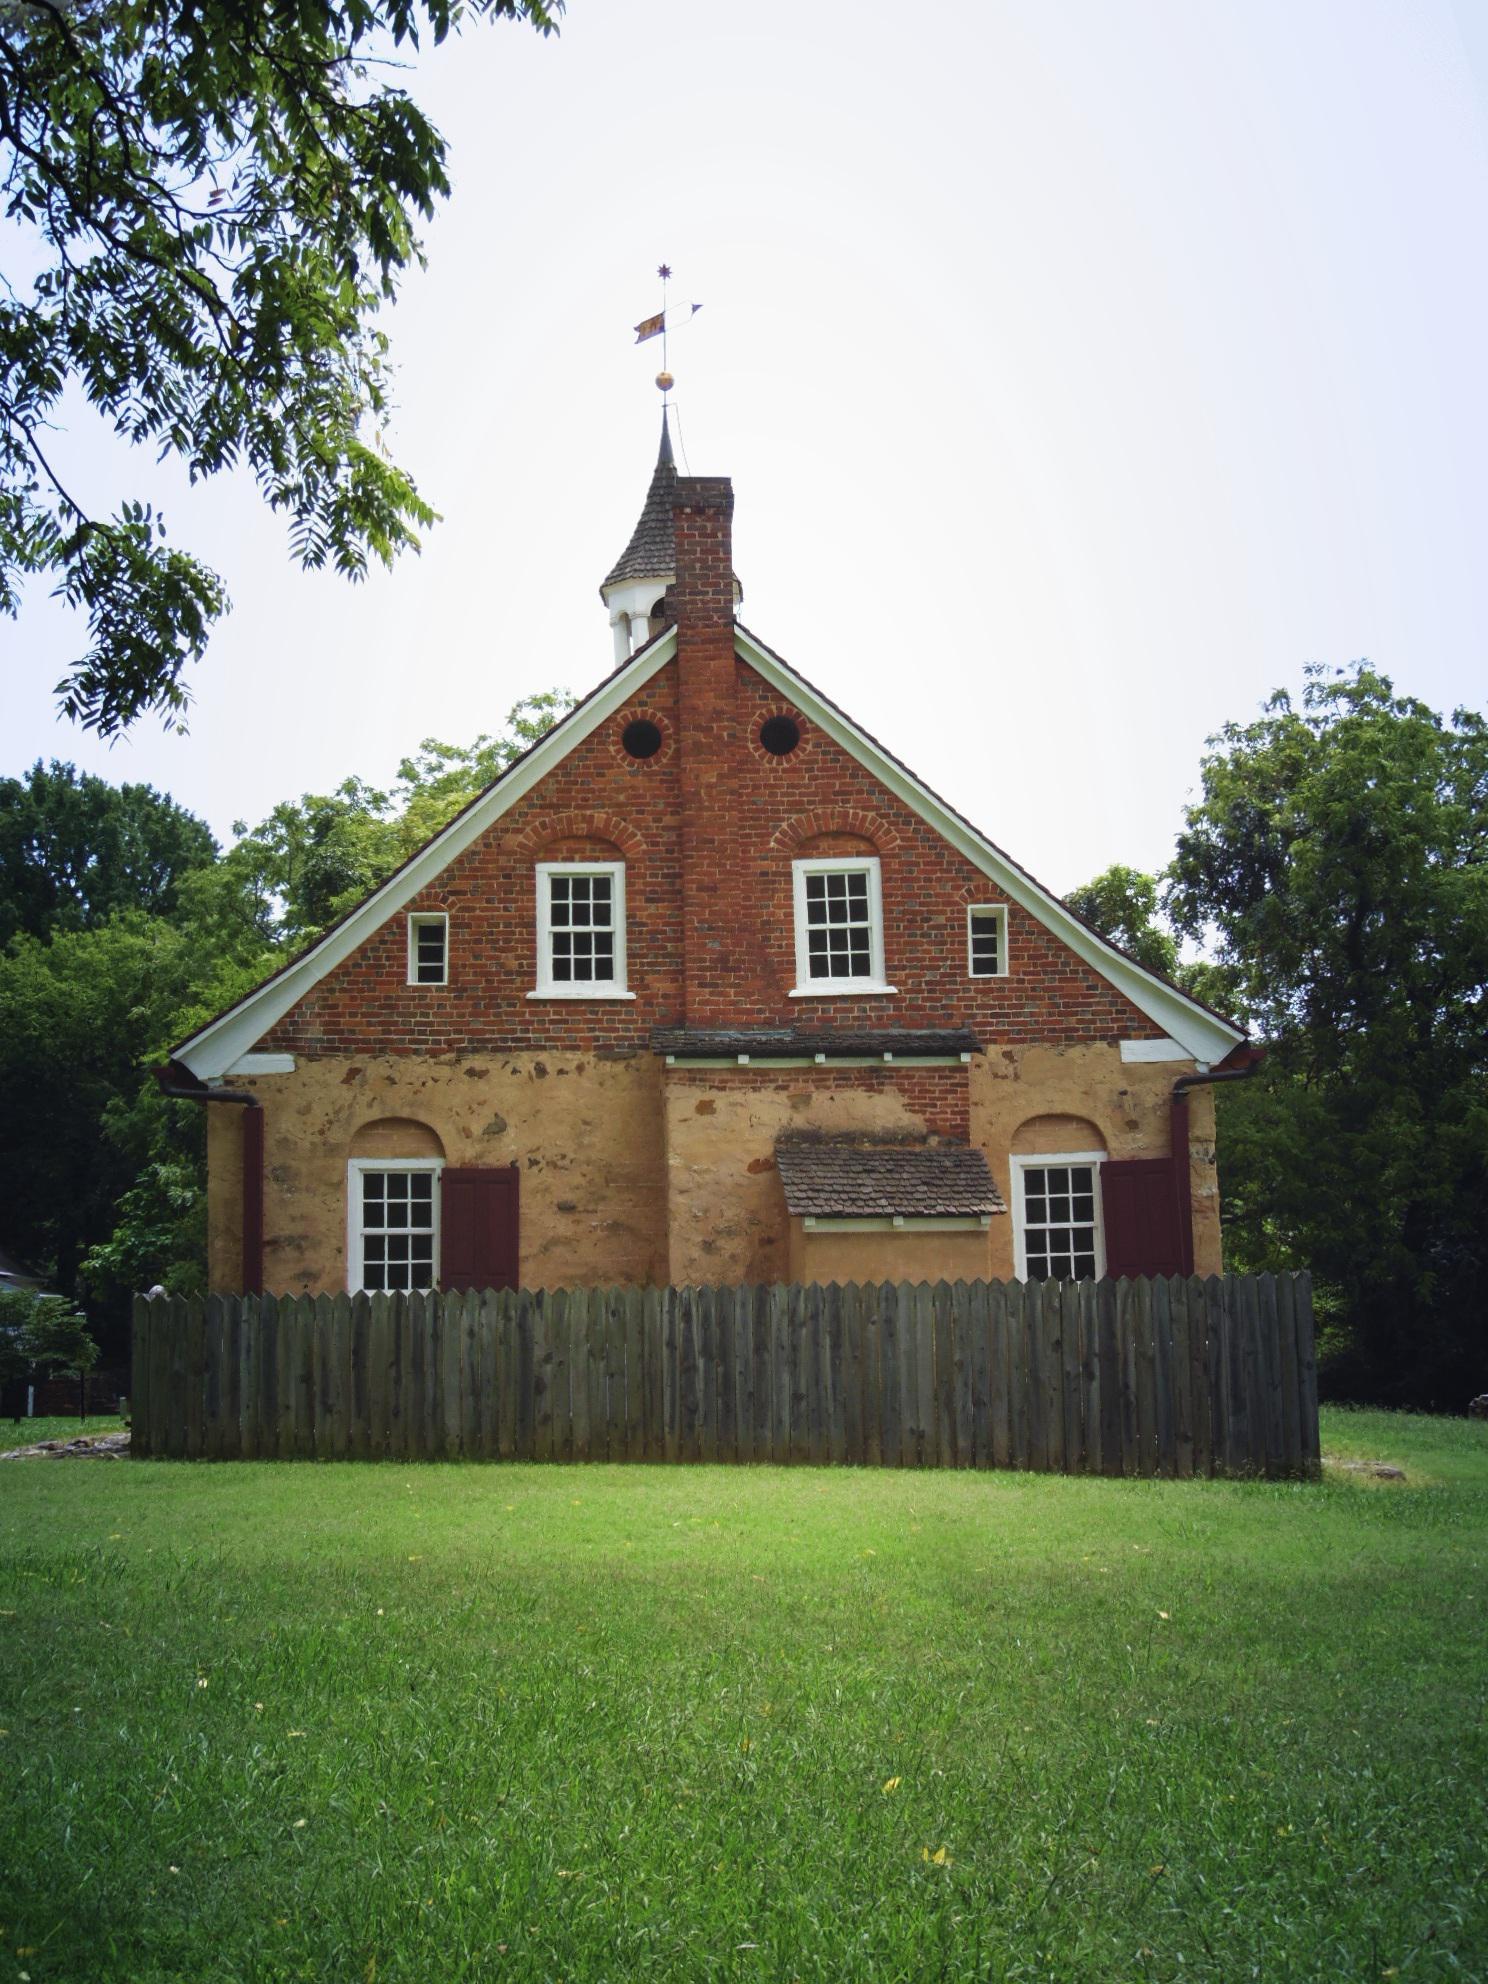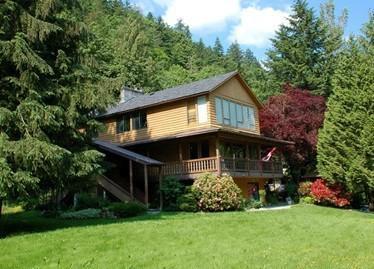The first image is the image on the left, the second image is the image on the right. Examine the images to the left and right. Is the description "There is a rocky cliff in at least one image." accurate? Answer yes or no. No. 